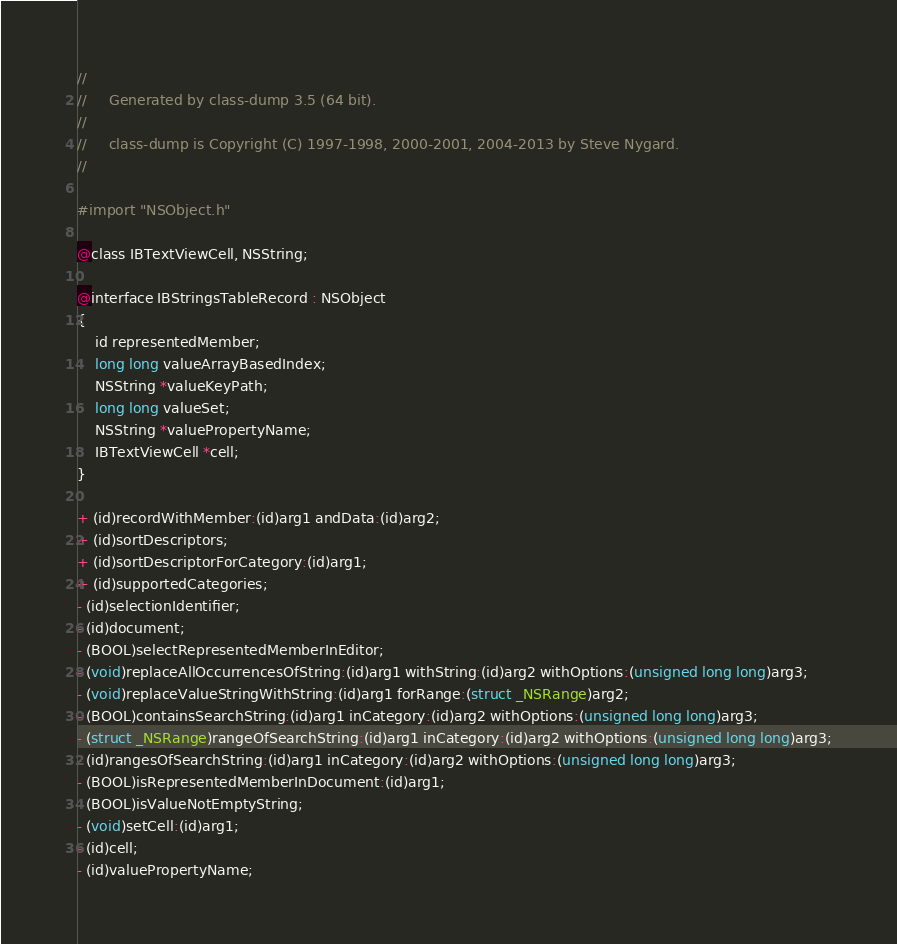Convert code to text. <code><loc_0><loc_0><loc_500><loc_500><_C_>//
//     Generated by class-dump 3.5 (64 bit).
//
//     class-dump is Copyright (C) 1997-1998, 2000-2001, 2004-2013 by Steve Nygard.
//

#import "NSObject.h"

@class IBTextViewCell, NSString;

@interface IBStringsTableRecord : NSObject
{
    id representedMember;
    long long valueArrayBasedIndex;
    NSString *valueKeyPath;
    long long valueSet;
    NSString *valuePropertyName;
    IBTextViewCell *cell;
}

+ (id)recordWithMember:(id)arg1 andData:(id)arg2;
+ (id)sortDescriptors;
+ (id)sortDescriptorForCategory:(id)arg1;
+ (id)supportedCategories;
- (id)selectionIdentifier;
- (id)document;
- (BOOL)selectRepresentedMemberInEditor;
- (void)replaceAllOccurrencesOfString:(id)arg1 withString:(id)arg2 withOptions:(unsigned long long)arg3;
- (void)replaceValueStringWithString:(id)arg1 forRange:(struct _NSRange)arg2;
- (BOOL)containsSearchString:(id)arg1 inCategory:(id)arg2 withOptions:(unsigned long long)arg3;
- (struct _NSRange)rangeOfSearchString:(id)arg1 inCategory:(id)arg2 withOptions:(unsigned long long)arg3;
- (id)rangesOfSearchString:(id)arg1 inCategory:(id)arg2 withOptions:(unsigned long long)arg3;
- (BOOL)isRepresentedMemberInDocument:(id)arg1;
- (BOOL)isValueNotEmptyString;
- (void)setCell:(id)arg1;
- (id)cell;
- (id)valuePropertyName;</code> 